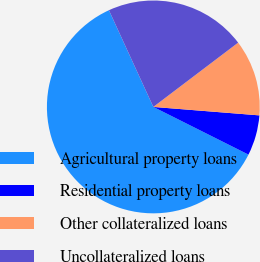Convert chart to OTSL. <chart><loc_0><loc_0><loc_500><loc_500><pie_chart><fcel>Agricultural property loans<fcel>Residential property loans<fcel>Other collateralized loans<fcel>Uncollateralized loans<nl><fcel>60.76%<fcel>6.13%<fcel>11.59%<fcel>21.53%<nl></chart> 